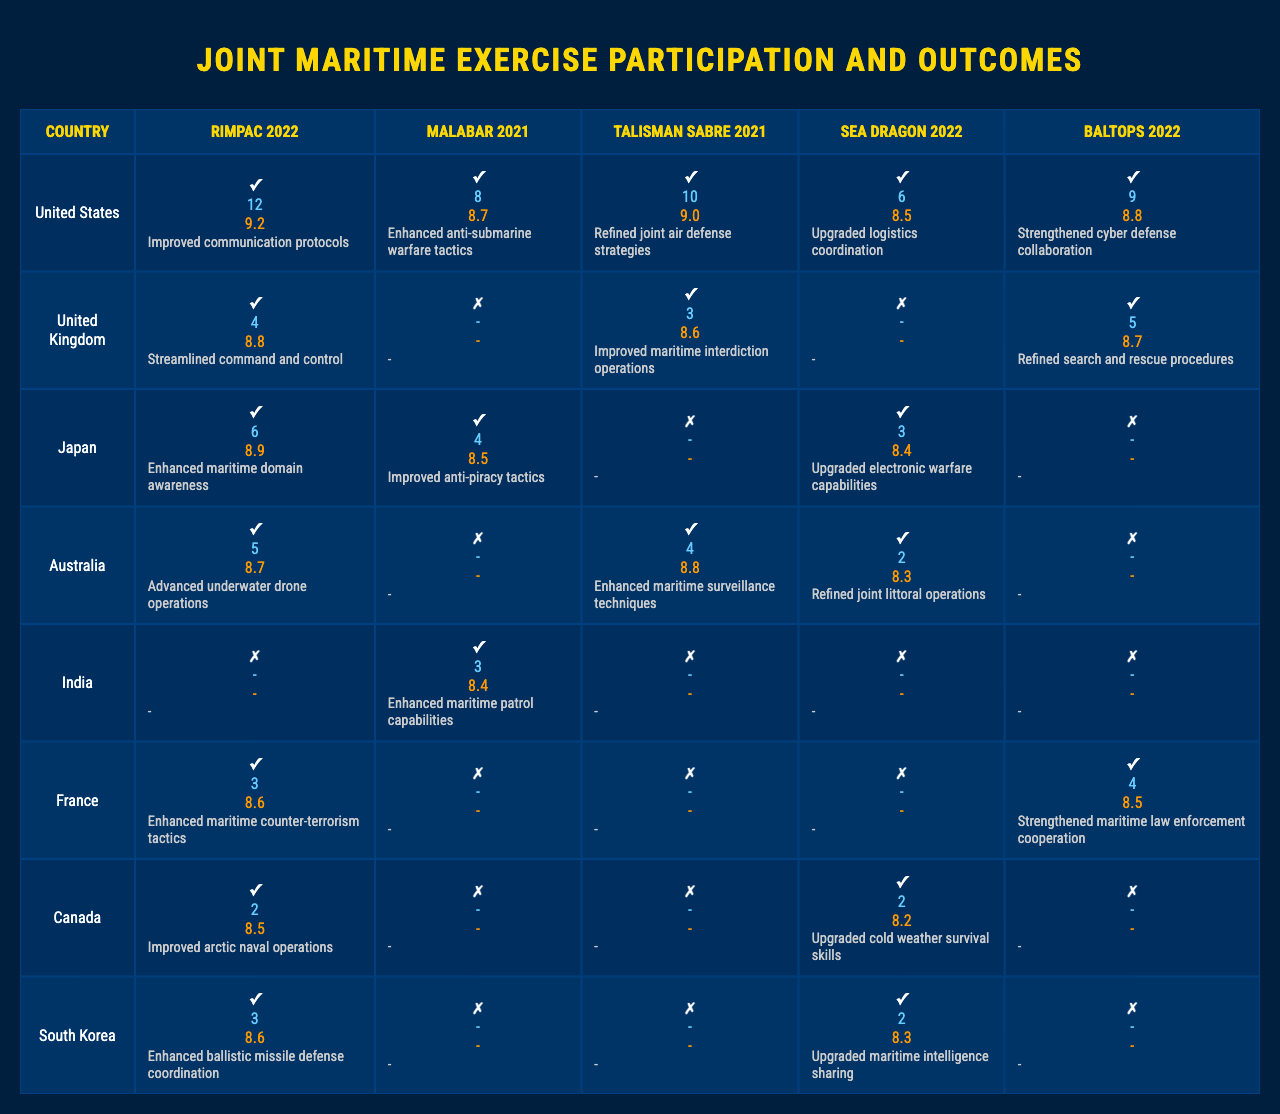What countries participated in RIMPAC 2022? The table shows that the countries participating in RIMPAC 2022 are the United States, United Kingdom, Japan, Australia, and France, as indicated by the checkmarks under RIMPAC 2022 for these countries.
Answer: United States, United Kingdom, Japan, Australia, France Which country had the highest interoperability score in Malabar 2021? By looking at the interoperability scores for the countries that participated in Malabar 2021, the United Kingdom did not participate, while India achieved a score of 8.4, which is the highest among the participating countries since Australia and France also had lower scores.
Answer: India How many vessels did the United States deploy in Talisman Sabre 2021? The table shows the number of vessels deployed by each country in Talisman Sabre 2021, and for the United States, it lists 6 vessels.
Answer: 6 Which country did not participate in BALTOPS 2022 but had a high interoperability score in other exercises? Examining the participation for BALTOPS 2022 reveals that India did not participate but had a high interoperability score in other exercises such as Malabar 2021 and RIMPAC 2022.
Answer: India What is the total number of vessels deployed by South Korea across all exercises? To find the total number of vessels for South Korea, we sum the vessels deployed: 3 (RIMPAC) + 0 (Malabar) + 2 (Talisman Sabre) + 2 (Sea Dragon) + 0 (BALTOPS) = 7.
Answer: 7 Did any country achieve a score of 9.0 or higher in any exercise? By checking the interoperability scores, the United States achieved a score of 9.2 in RIMPAC 2022, which is 9.0 or higher; therefore, the answer is yes.
Answer: Yes Which country participated in the most exercises and what is its average interoperability score? The United States participated in all five exercises, and to find the average interoperability score: (9.2 + 8.8 + 8.9 + 8.7 + 8.6) / 5 = 8.84.
Answer: United States; 8.84 What lesson was learned regarding cyber defense collaboration in RIMPAC 2022? The lessons learned indicate that "Strengthened cyber defense collaboration" was specifically noted in RIMPAC 2022 for the United States, confirming its importance.
Answer: Strengthened cyber defense collaboration Which exercise had the lowest total number of vessels deployed? Calculating total vessels for each exercise shows that Malabar 2021 had a total of 7 vessels deployed (4 by the United Kingdom and 3 by India); whereas the others had higher totals, marking it the lowest.
Answer: Malabar 2021 What was the primary focus of the lessons learned from the exercises by Australia? Reviewing the lessons learned reveals that Australia primarily focused on "Advanced underwater drone operations," "Improved maritime strike capabilities," and several others, indicating their focus on enhancing maritime mission capabilities.
Answer: Advanced underwater drone operations, Improved maritime strike capabilities 